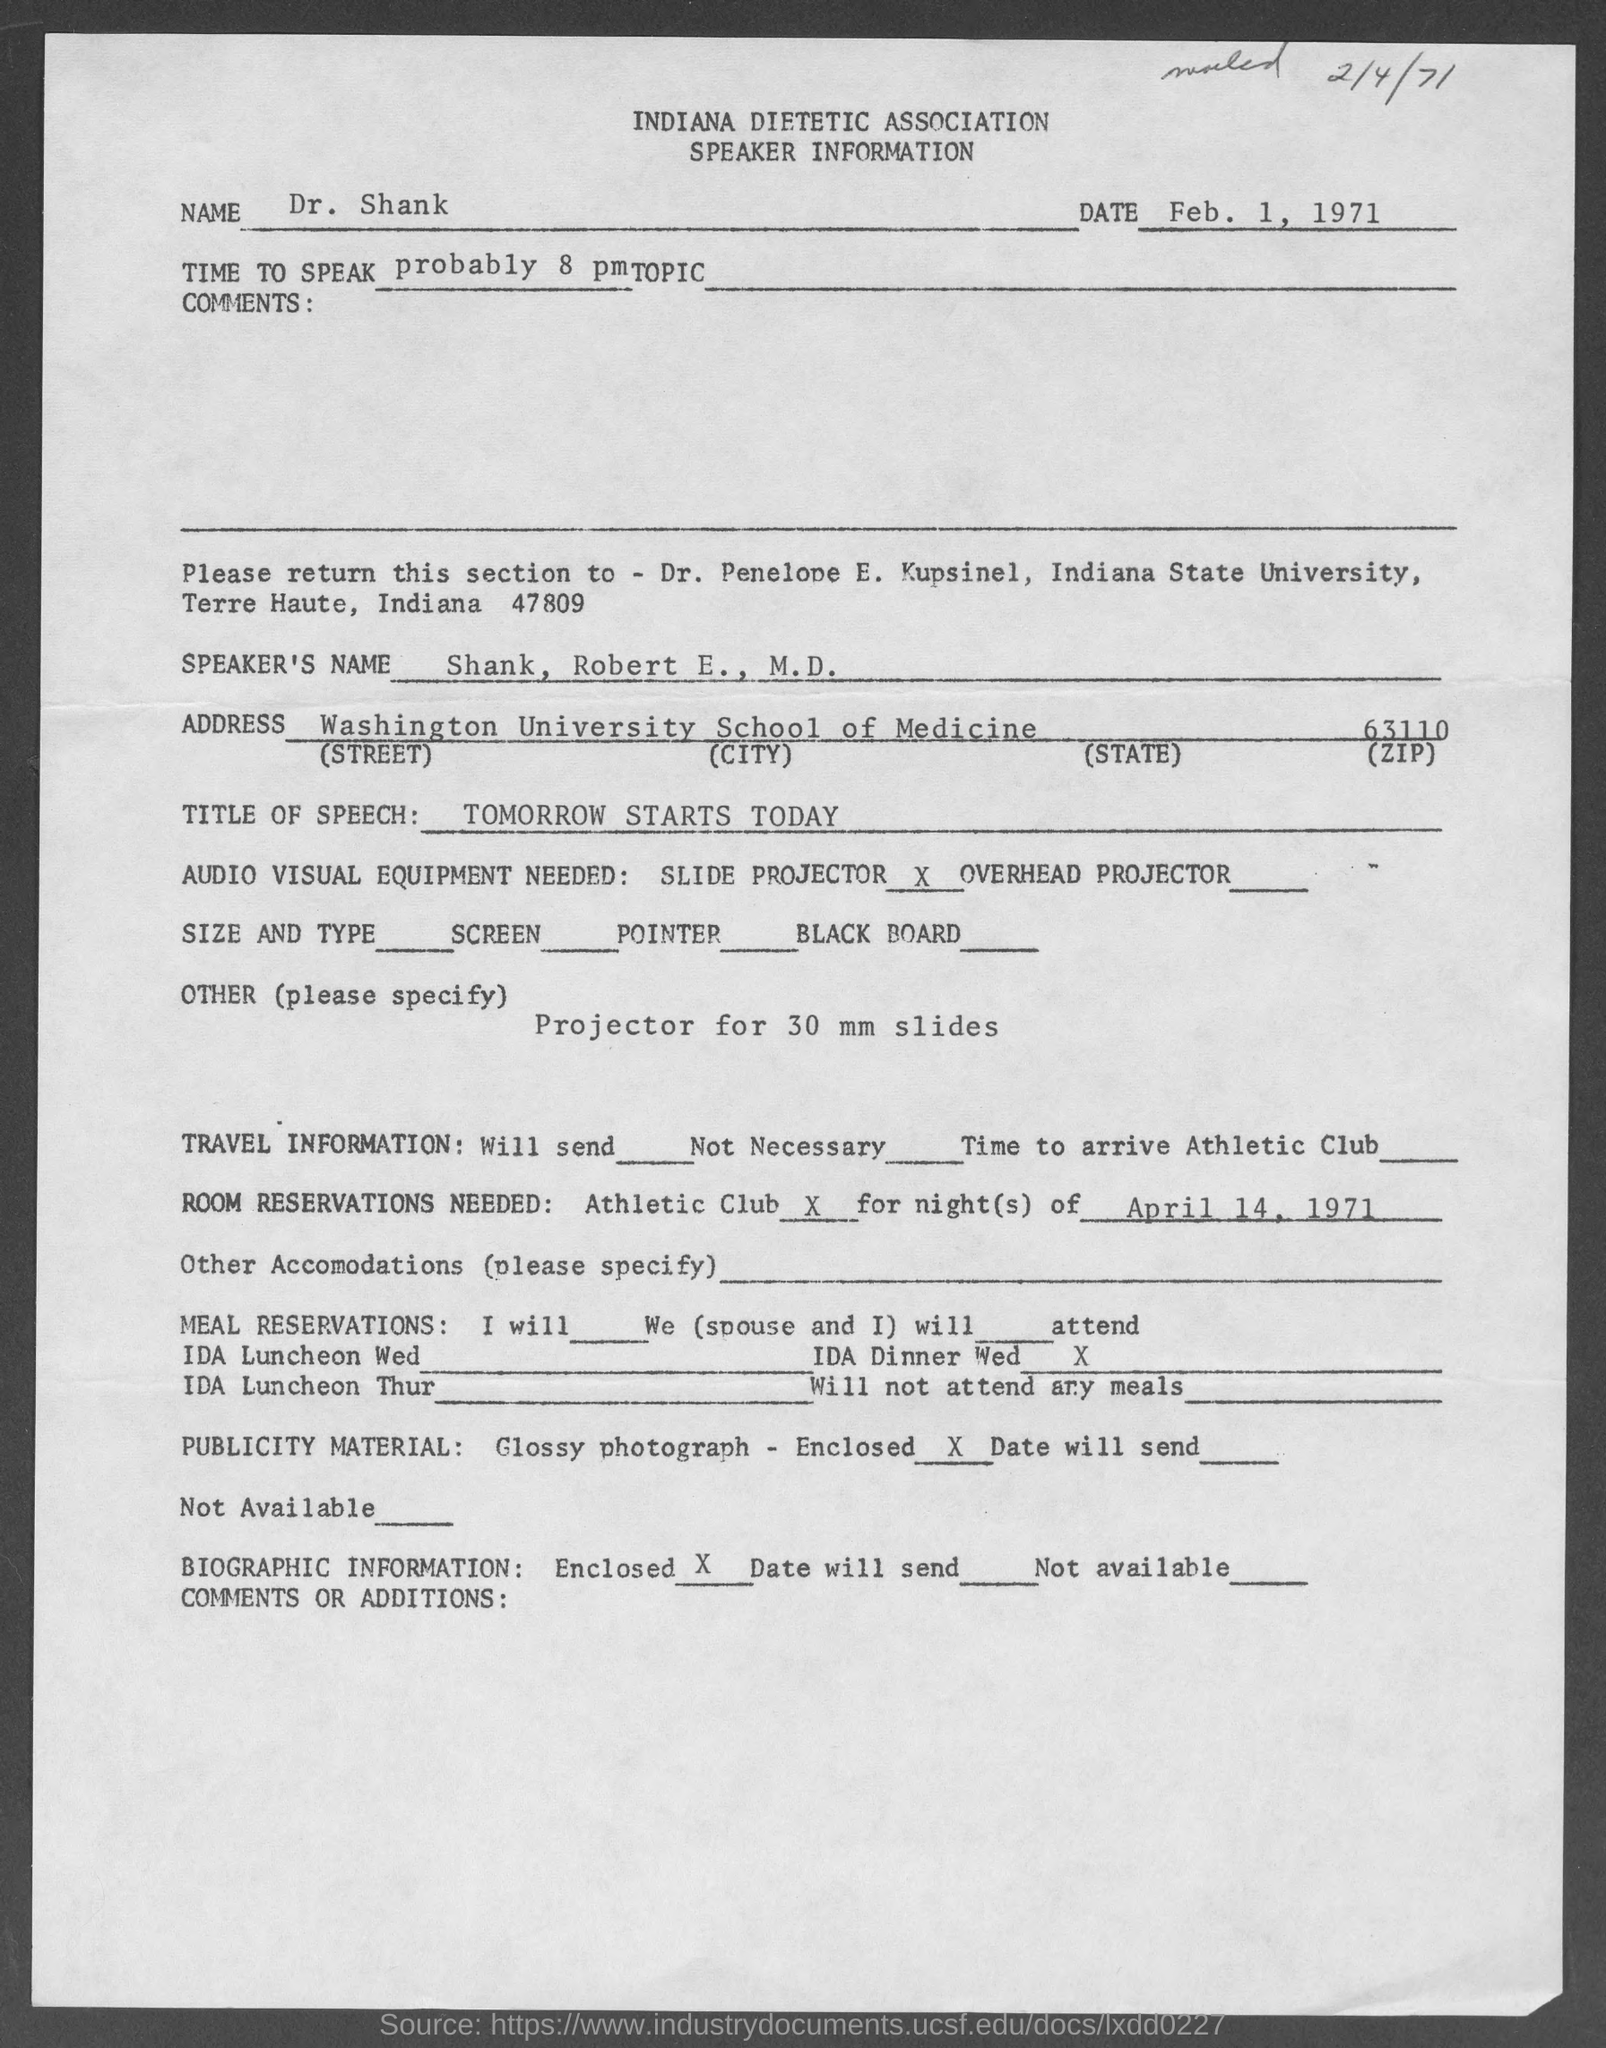What is the zipcode ?
Your answer should be very brief. 63110. In which state is indiana state university located ?
Offer a very short reply. Indiana. What is the title of speech?
Your answer should be compact. Tomorrow starts today. 